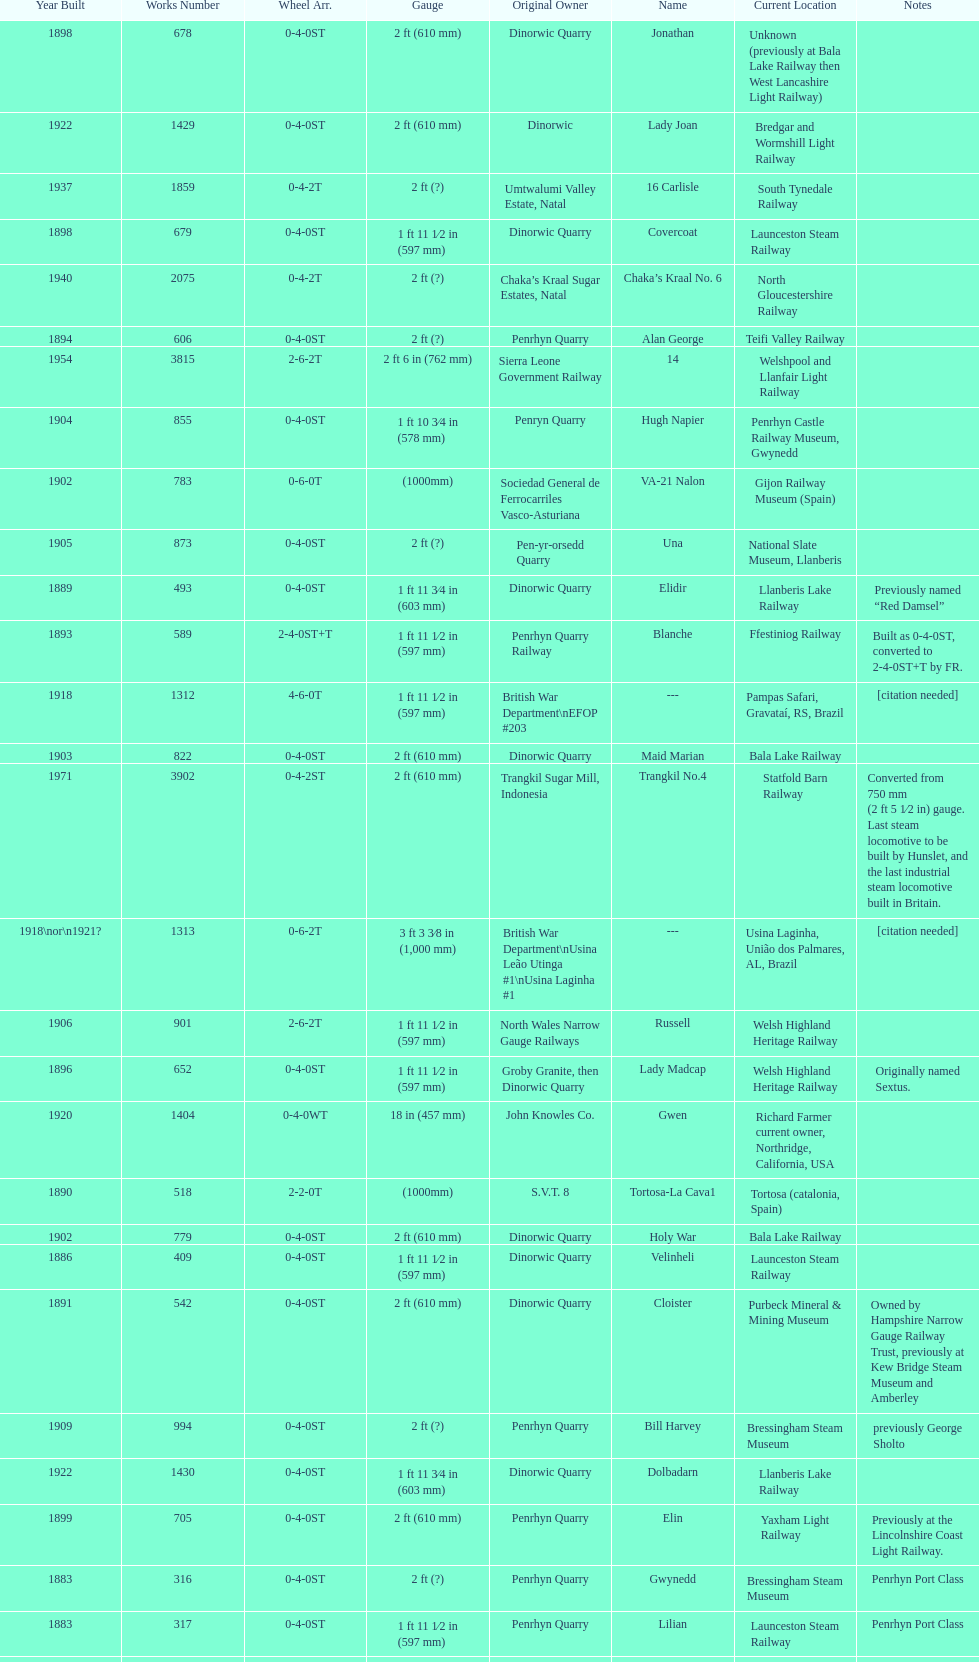What is the difference in gauge between works numbers 541 and 542? 32 mm. 